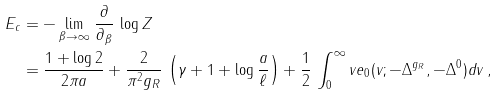<formula> <loc_0><loc_0><loc_500><loc_500>E _ { c } & = - \lim _ { \beta \to \infty } \, \frac { \partial } { \partial _ { \beta } } \, \log Z \\ & = \frac { 1 + \log 2 } { 2 \pi a } + \frac { 2 } { \pi ^ { 2 } g _ { R } } \, \left ( \gamma + 1 + \log \frac { a } { \ell } \right ) + \frac { 1 } { 2 } \, \int _ { 0 } ^ { \infty } v e _ { 0 } ( v ; - \Delta ^ { g _ { R } } , - \Delta ^ { 0 } ) d v \, ,</formula> 